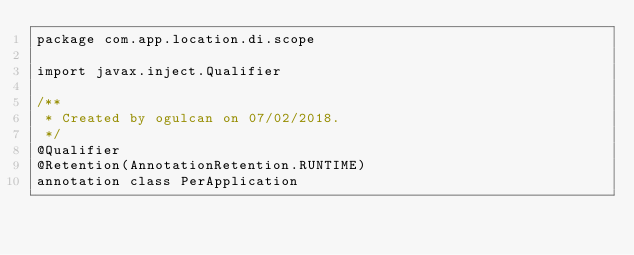Convert code to text. <code><loc_0><loc_0><loc_500><loc_500><_Kotlin_>package com.app.location.di.scope

import javax.inject.Qualifier

/**
 * Created by ogulcan on 07/02/2018.
 */
@Qualifier
@Retention(AnnotationRetention.RUNTIME)
annotation class PerApplication</code> 